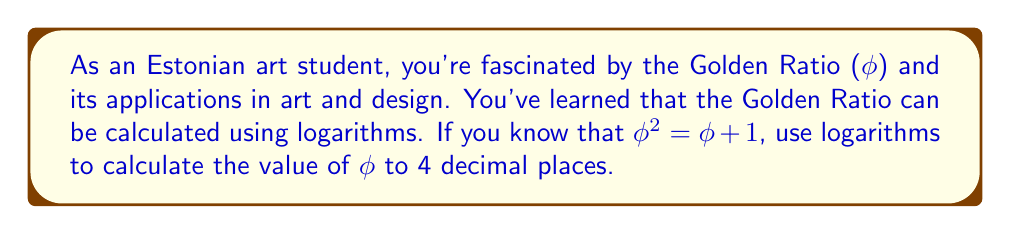Can you solve this math problem? Let's approach this step-by-step:

1) We start with the equation: φ² = φ + 1

2) Subtract φ from both sides:
   φ² - φ = 1

3) Factor out φ:
   φ(φ - 1) = 1

4) Divide both sides by (φ - 1):
   φ = 1 / (φ - 1)

5) Add 1 to both sides:
   φ + 1 = 1 / (φ - 1) + 1

6) Simplify the right side:
   φ + 1 = φ / (φ - 1)

7) Now, let's take the logarithm of both sides. We can use any base, but let's use the natural logarithm (ln):
   ln(φ + 1) = ln(φ / (φ - 1))

8) Use the logarithm property ln(a/b) = ln(a) - ln(b):
   ln(φ + 1) = ln(φ) - ln(φ - 1)

9) Rearrange:
   ln(φ - 1) = ln(φ) - ln(φ + 1)

10) Use the property ln(a) - ln(b) = ln(a/b):
    ln(φ - 1) = ln(φ / (φ + 1))

11) Take e to the power of both sides:
    φ - 1 = φ / (φ + 1)

12) Multiply both sides by (φ + 1):
    (φ - 1)(φ + 1) = φ

13) Expand:
    φ² - 1 = φ

14) Rearrange:
    φ² - φ - 1 = 0

15) This is a quadratic equation. We can solve it using the quadratic formula:
    φ = (-b ± √(b² - 4ac)) / (2a)
    where a = 1, b = -1, and c = -1

16) Plugging in these values:
    φ = (1 ± √(1² - 4(1)(-1))) / (2(1))
    φ = (1 ± √5) / 2

17) Since φ is positive, we take the positive root:
    φ = (1 + √5) / 2

18) Calculate this value:
    φ ≈ 1.6180339887...

Rounding to 4 decimal places, we get 1.6180.
Answer: φ ≈ 1.6180 